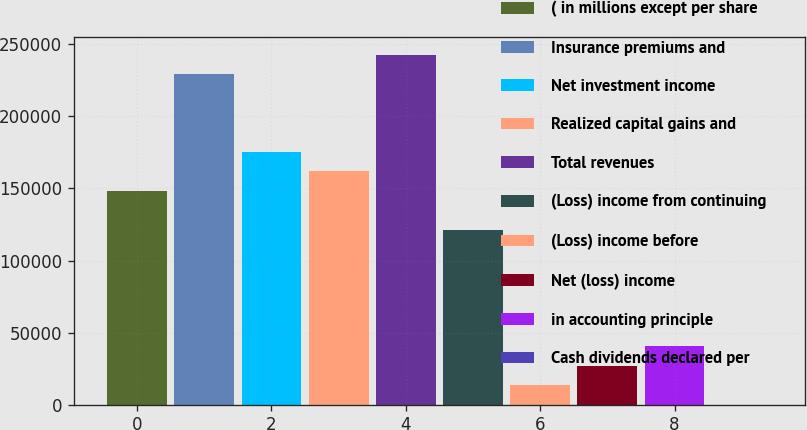Convert chart. <chart><loc_0><loc_0><loc_500><loc_500><bar_chart><fcel>( in millions except per share<fcel>Insurance premiums and<fcel>Net investment income<fcel>Realized capital gains and<fcel>Total revenues<fcel>(Loss) income from continuing<fcel>(Loss) income before<fcel>Net (loss) income<fcel>in accounting principle<fcel>Cash dividends declared per<nl><fcel>148278<fcel>229156<fcel>175237<fcel>161757<fcel>242635<fcel>121318<fcel>13481.3<fcel>26960.9<fcel>40440.6<fcel>1.64<nl></chart> 